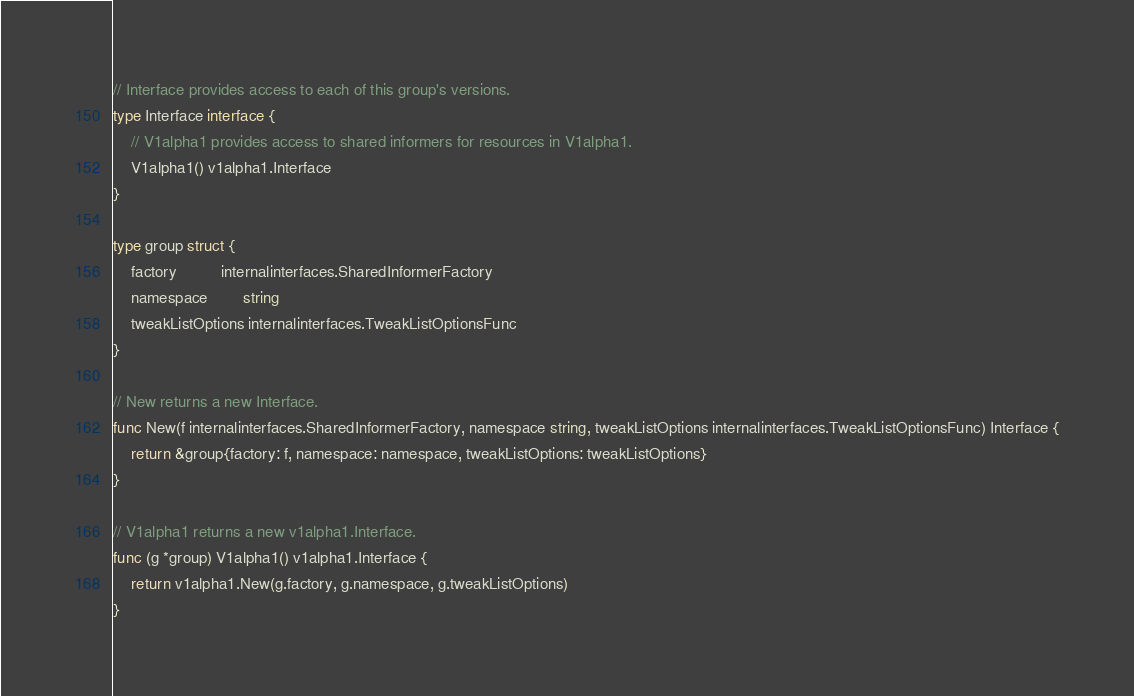<code> <loc_0><loc_0><loc_500><loc_500><_Go_>
// Interface provides access to each of this group's versions.
type Interface interface {
	// V1alpha1 provides access to shared informers for resources in V1alpha1.
	V1alpha1() v1alpha1.Interface
}

type group struct {
	factory          internalinterfaces.SharedInformerFactory
	namespace        string
	tweakListOptions internalinterfaces.TweakListOptionsFunc
}

// New returns a new Interface.
func New(f internalinterfaces.SharedInformerFactory, namespace string, tweakListOptions internalinterfaces.TweakListOptionsFunc) Interface {
	return &group{factory: f, namespace: namespace, tweakListOptions: tweakListOptions}
}

// V1alpha1 returns a new v1alpha1.Interface.
func (g *group) V1alpha1() v1alpha1.Interface {
	return v1alpha1.New(g.factory, g.namespace, g.tweakListOptions)
}
</code> 